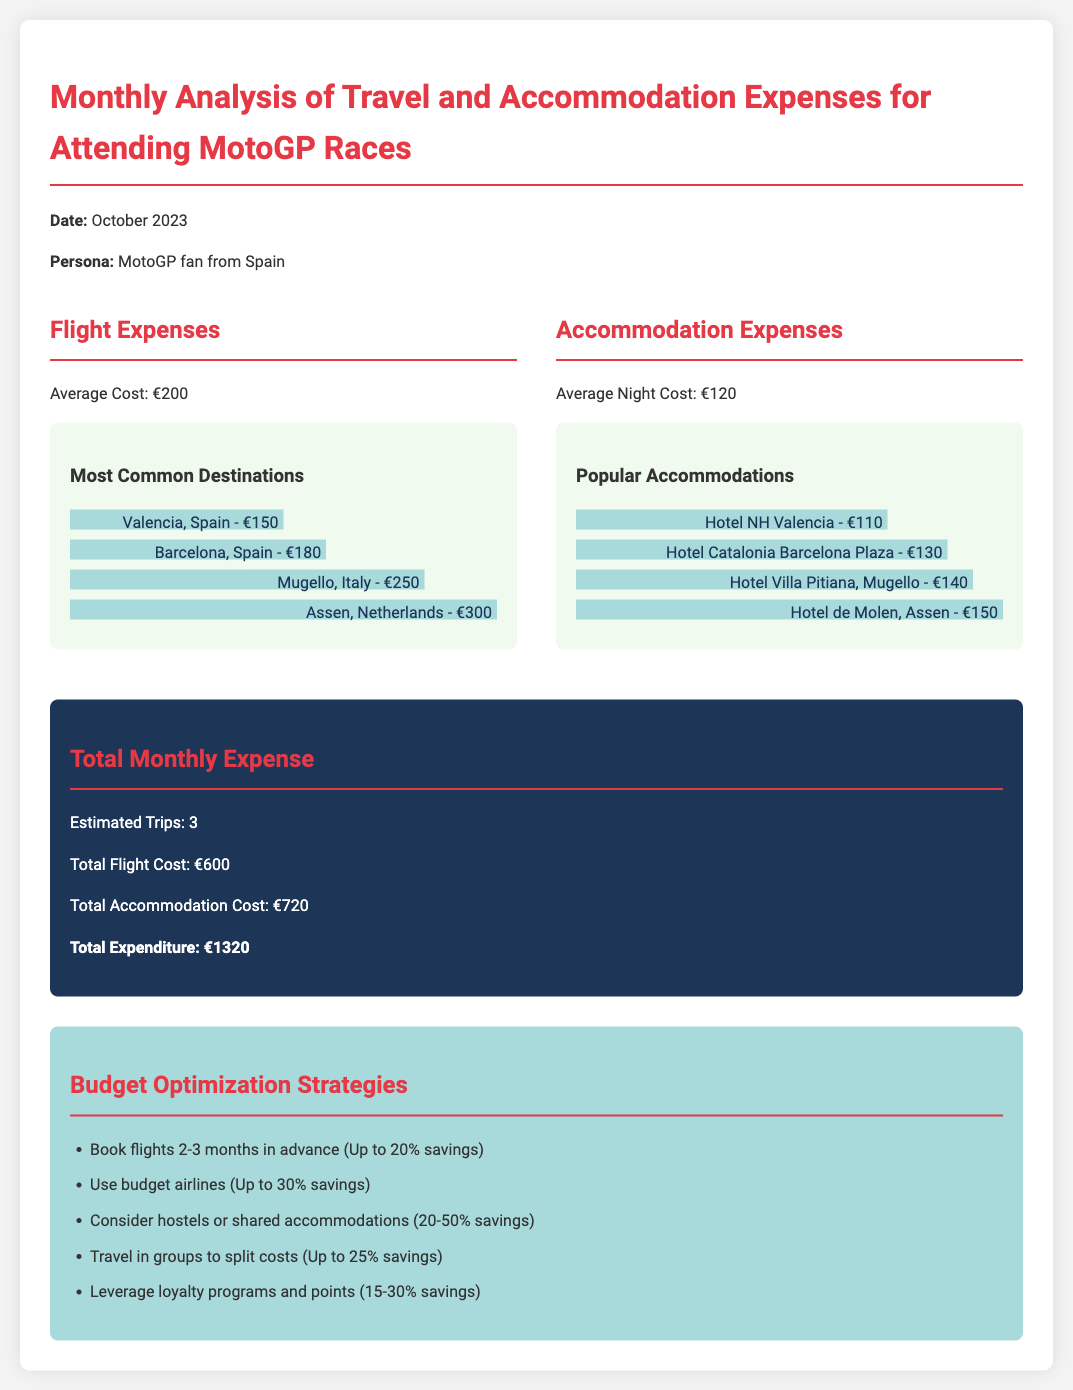What is the average flight cost? The average flight cost is stated in the document as €200.
Answer: €200 What is the total accommodation cost? The total accommodation cost is calculated as €120 per night multiplied by an estimated 6 nights (3 trips). Thus, total accommodation cost is €720.
Answer: €720 What is the most common destination listed? The chart shows Valencia, Spain, as the most common destination with a cost of €150.
Answer: Valencia, Spain How much can you save by booking flights in advance? The document states that booking flights 2-3 months in advance can lead to savings of up to 20%.
Answer: Up to 20% What is the estimated number of trips mentioned? The document mentions an estimated number of trips as 3.
Answer: 3 Which hotel has the highest accommodation cost? The highest accommodation cost listed is for Hotel de Molen, Assen at €150.
Answer: Hotel de Molen, Assen What is the total expenditure for the month? The total expenditure is calculated as the sum of total flight cost (€600) and total accommodation cost (€720), which is €1320.
Answer: €1320 How much can be saved by using budget airlines? The document indicates that using budget airlines can save up to 30%.
Answer: Up to 30% Which city has the highest flight cost? The flight to Assen, Netherlands has the highest cost at €300 according to the document.
Answer: Assen, Netherlands 